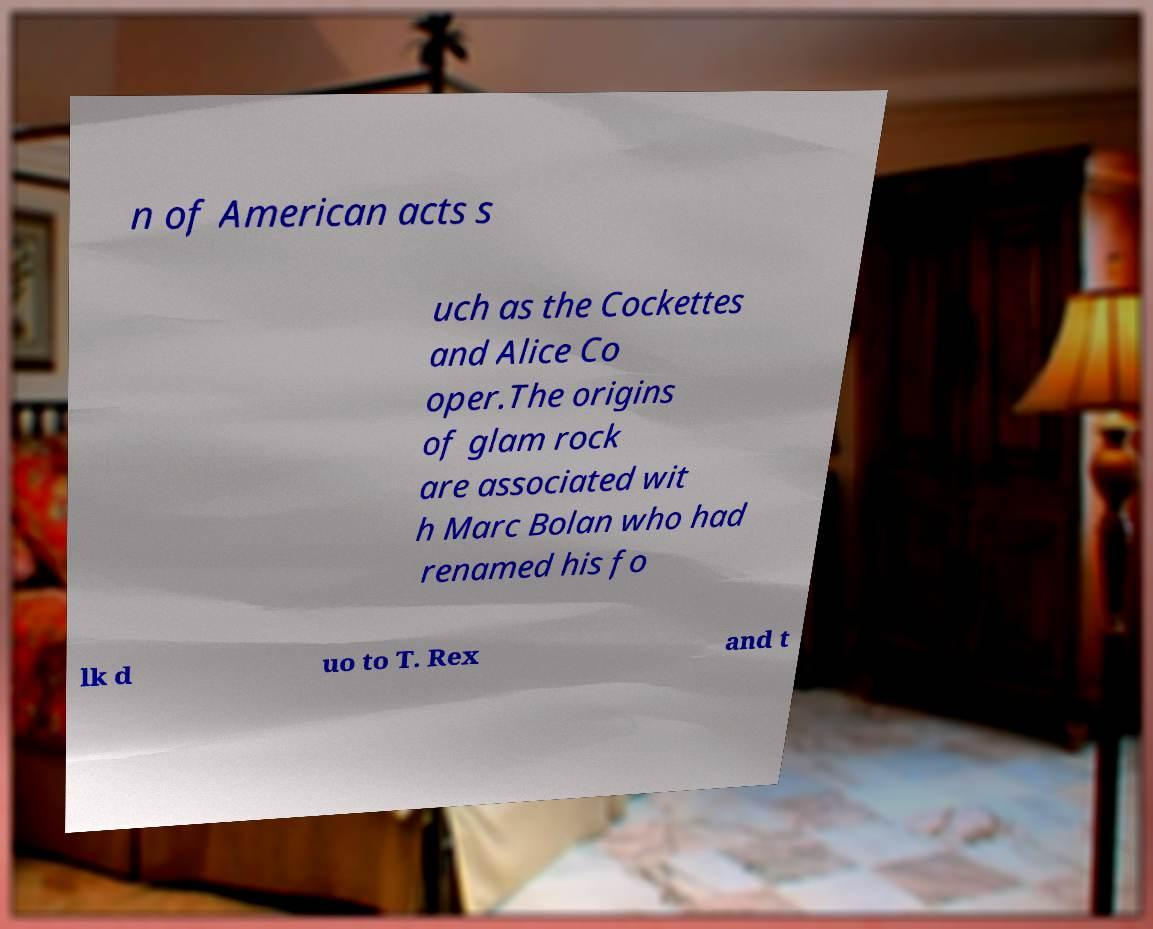Please identify and transcribe the text found in this image. n of American acts s uch as the Cockettes and Alice Co oper.The origins of glam rock are associated wit h Marc Bolan who had renamed his fo lk d uo to T. Rex and t 